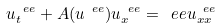<formula> <loc_0><loc_0><loc_500><loc_500>u ^ { \ e e } _ { t } + A ( u ^ { \ e e } ) u ^ { \ e e } _ { x } = \ e e u ^ { \ e e } _ { x x }</formula> 